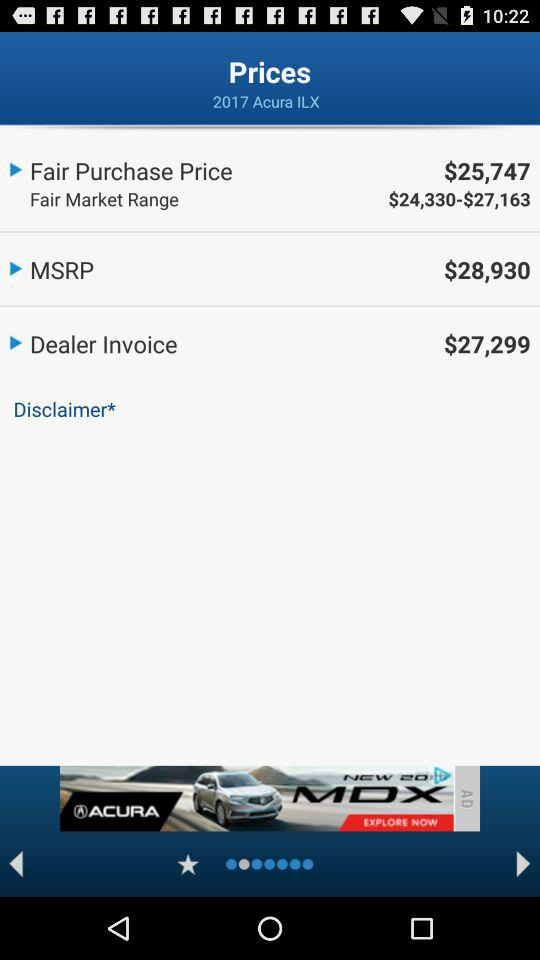What is the fair market range of the "2017 Acura ILX"? The fair market range of the "2017 Acura ILX" is between $24,330 and $27,163. 